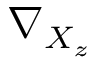<formula> <loc_0><loc_0><loc_500><loc_500>\nabla _ { X _ { z } }</formula> 